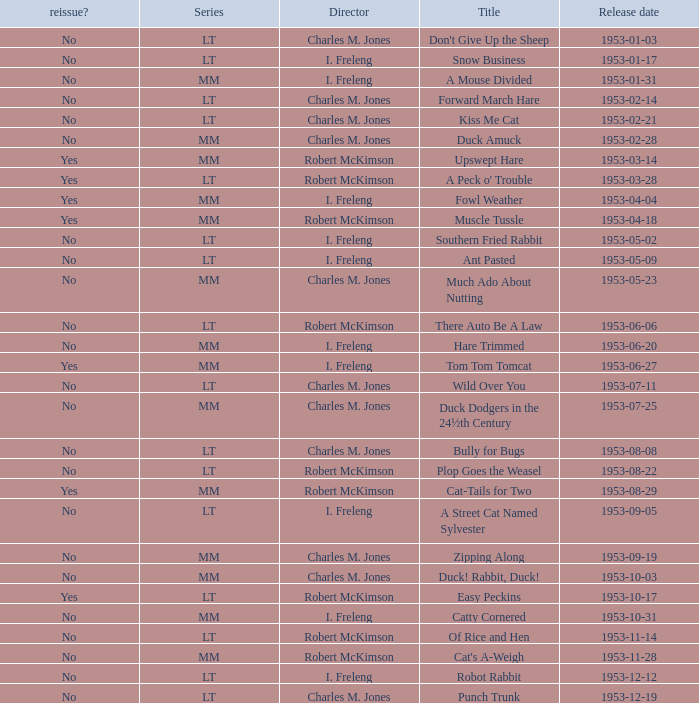Was there a reissue of the film released on 1953-10-03? No. 